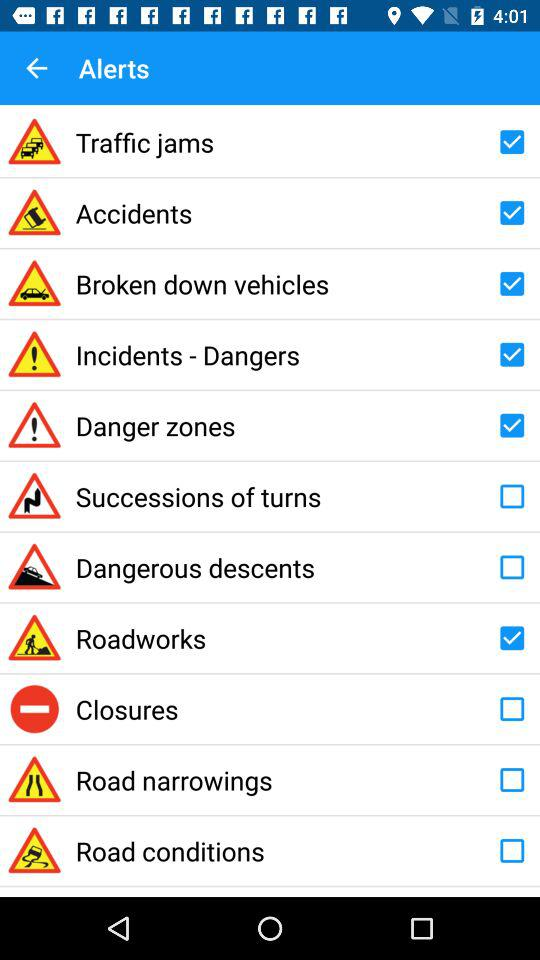What is the status of "Accidents"? The status of "Accidents" is "on". 